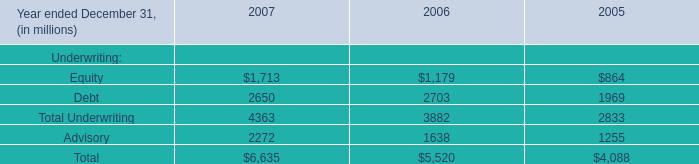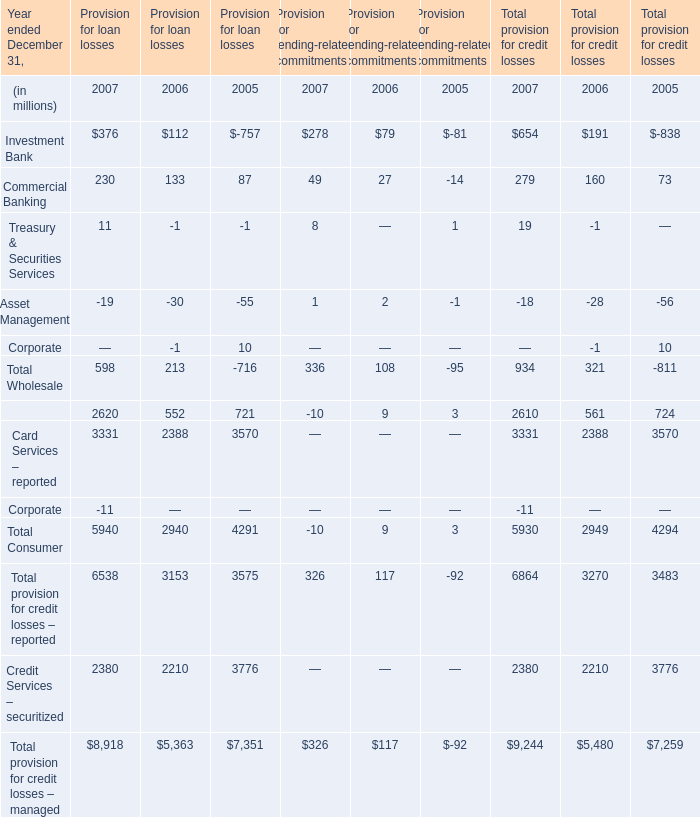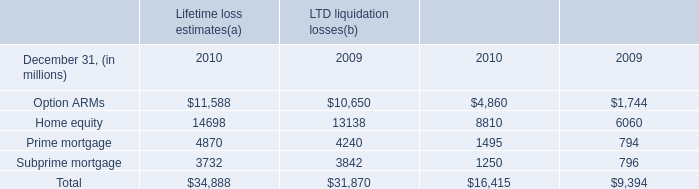What's the average of Credit Services – securitized of Provision for loan losses 2005, and Option ARMs of Lifetime loss estimates 2010 ? 
Computations: ((3776.0 + 11588.0) / 2)
Answer: 7682.0. 